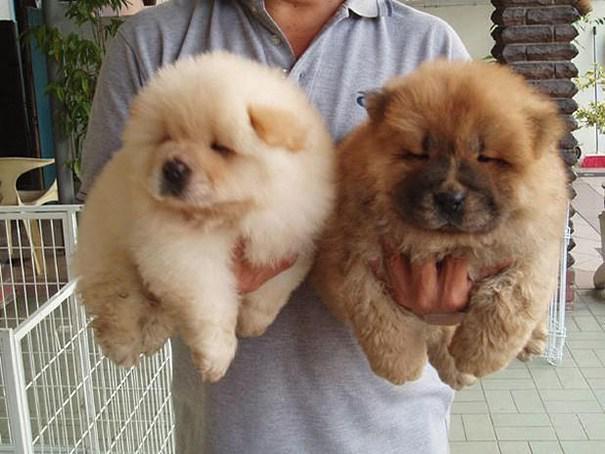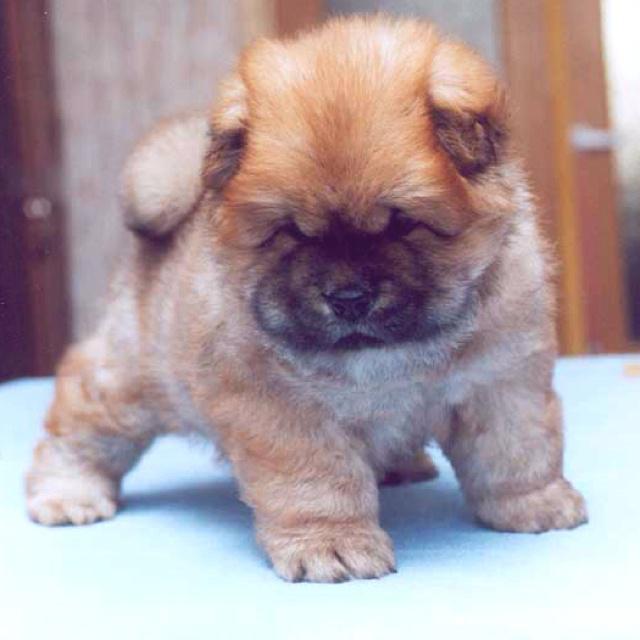The first image is the image on the left, the second image is the image on the right. For the images displayed, is the sentence "One image shows a chow dog posed in front of something with green foliage, and each image contains a single dog." factually correct? Answer yes or no. No. The first image is the image on the left, the second image is the image on the right. Assess this claim about the two images: "The dog in the image on the left is lying down.". Correct or not? Answer yes or no. No. 